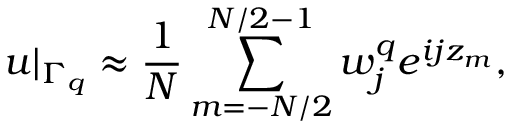Convert formula to latex. <formula><loc_0><loc_0><loc_500><loc_500>u | _ { \Gamma _ { q } } \approx \frac { 1 } { N } \sum _ { m = - N / 2 } ^ { N / 2 - 1 } w _ { j } ^ { q } e ^ { i j z _ { m } } ,</formula> 